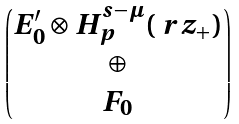<formula> <loc_0><loc_0><loc_500><loc_500>\begin{pmatrix} E _ { 0 } ^ { \prime } \otimes H ^ { s - \mu } _ { p } ( \ r z _ { + } ) \\ \oplus \\ F _ { 0 } \end{pmatrix}</formula> 